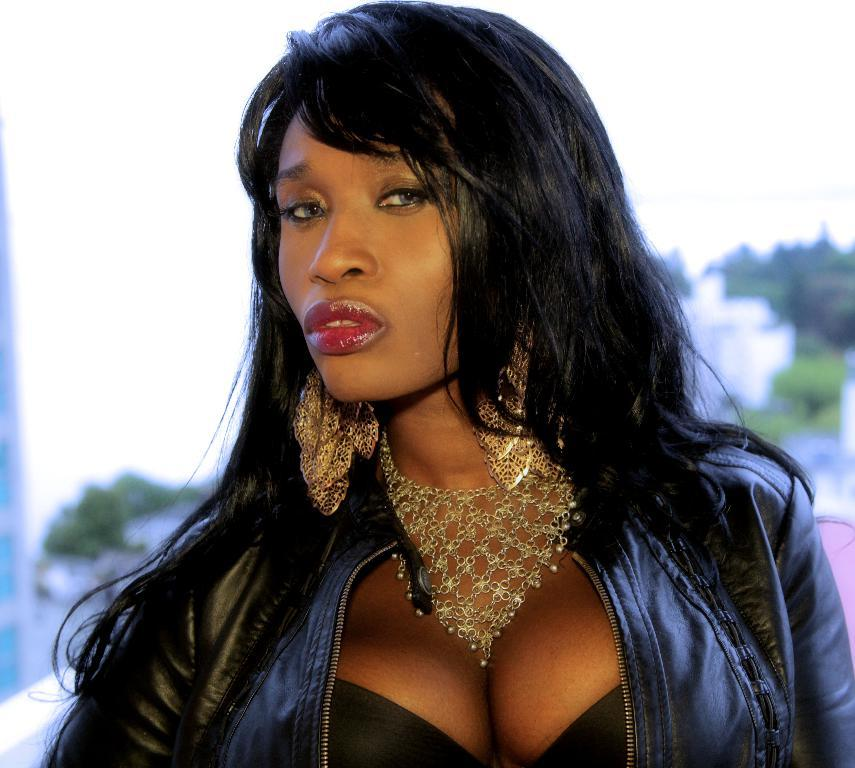Who is the main subject in the image? There is a woman in the image. What is the woman wearing? The woman is wearing a jacket. What can be seen in the background of the image? There are trees in the background of the image. How would you describe the background of the image? The background is blurry. What type of flesh can be seen on the doll in the image? There is no doll present in the image, and therefore no flesh can be seen. 